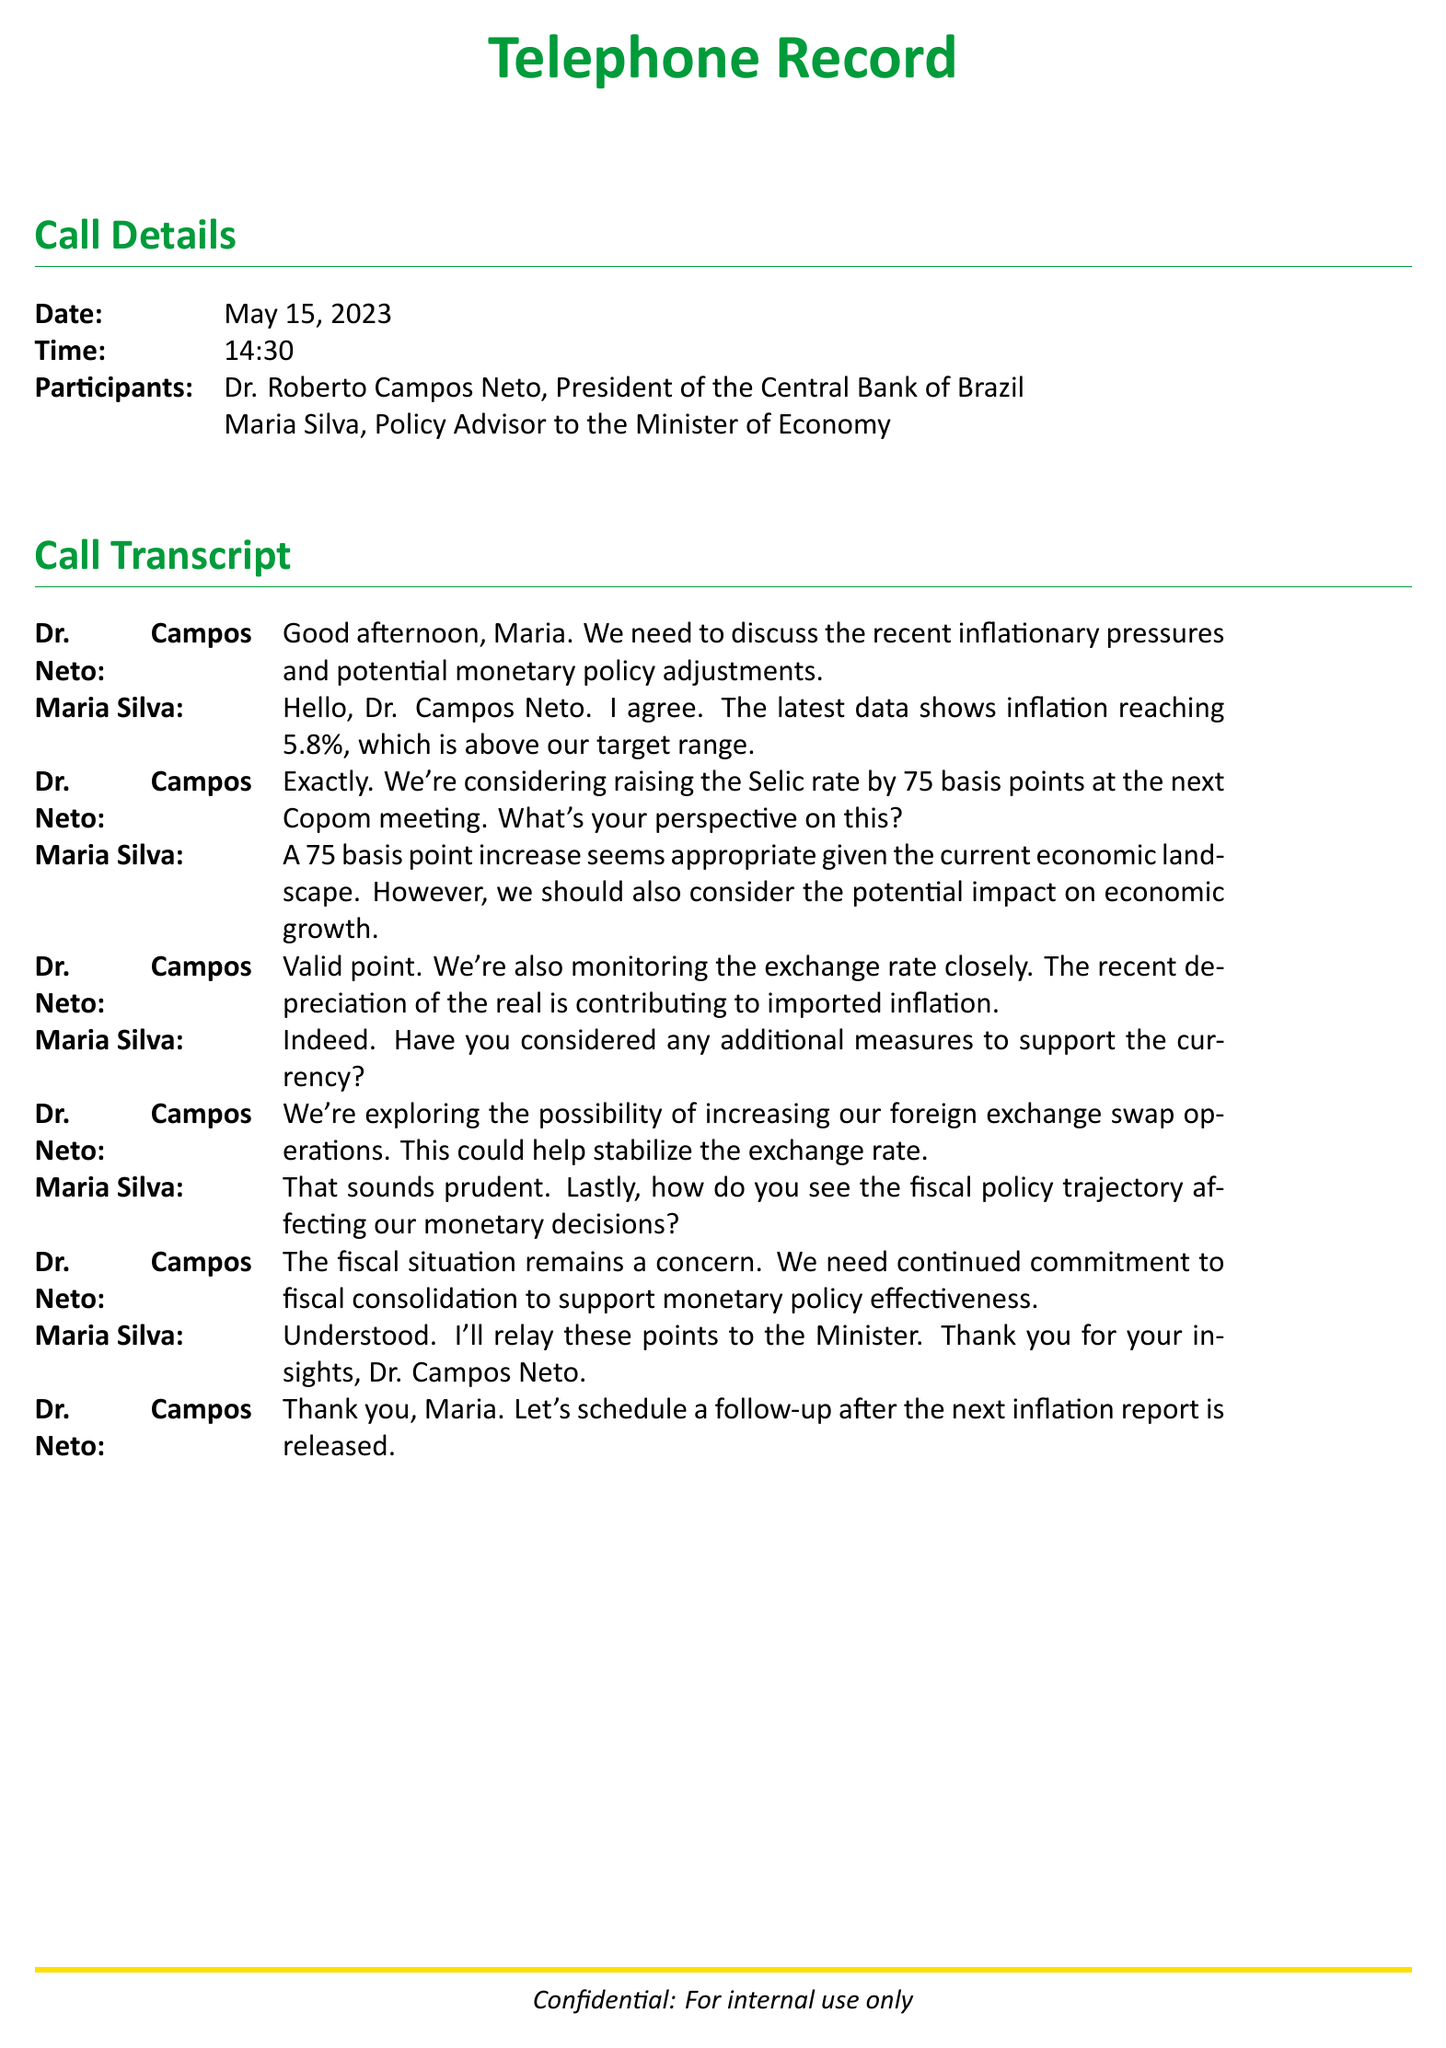What is the date of the call? The date of the call is mentioned in the call details section, which states May 15, 2023.
Answer: May 15, 2023 Who is the President of the Central Bank of Brazil? The document identifies Dr. Roberto Campos Neto as the President of the Central Bank of Brazil.
Answer: Dr. Roberto Campos Neto What is the proposed increase in the Selic rate? The document states that the Central Bank is considering a 75 basis point increase at the next Copom meeting.
Answer: 75 basis points What inflation rate is mentioned in the conversation? The inflation rate discussed in the document is stated as reaching 5.8%.
Answer: 5.8% What economic factor is Dr. Campos Neto monitoring closely? Dr. Campos Neto mentions closely monitoring the exchange rate, which is an economic factor affecting inflation.
Answer: Exchange rate What measure is being explored to stabilize the currency? The document mentions the possibility of increasing foreign exchange swap operations as a measure to stabilize the currency.
Answer: Increasing foreign exchange swap operations What concern does Dr. Campos Neto raise about fiscal policy? Dr. Campos Neto expresses concern about the fiscal situation affecting the effectiveness of monetary policy.
Answer: Fiscal situation What will Maria Silva do with the insights from the call? Maria Silva states that she will relay these points to the Minister of Economy.
Answer: Relay these points to the Minister 